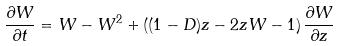<formula> <loc_0><loc_0><loc_500><loc_500>\frac { \partial W } { \partial t } = W - W ^ { 2 } + \left ( ( 1 - D ) z - 2 z W - 1 \right ) \frac { \partial W } { \partial z }</formula> 